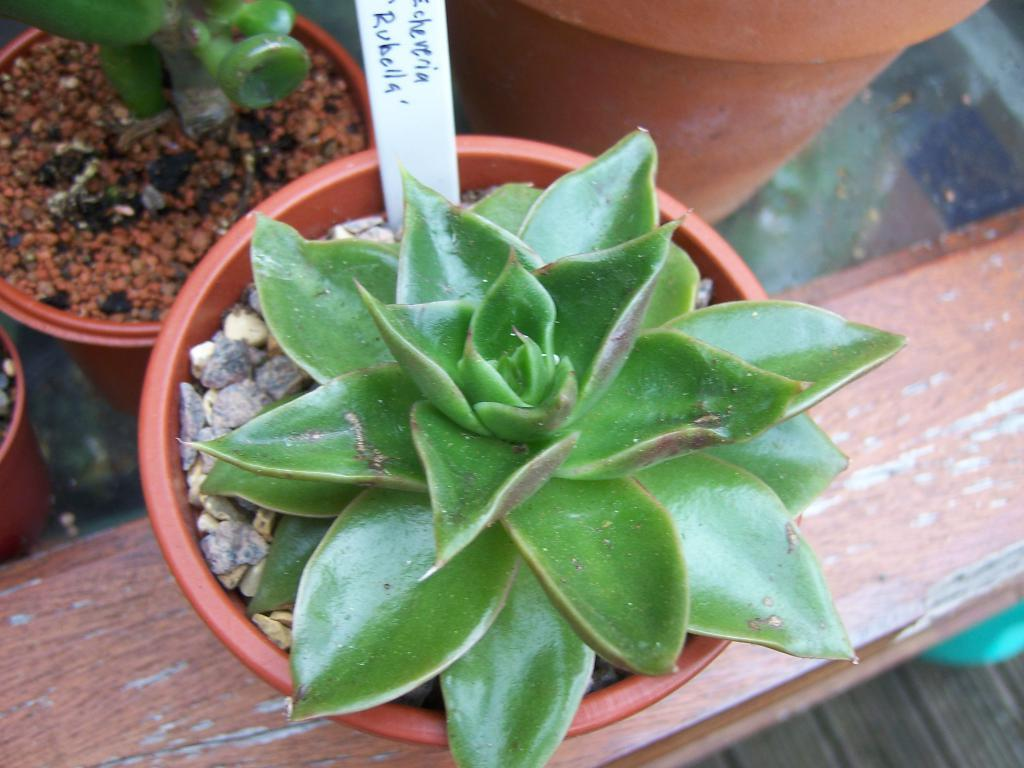What type of living organisms can be seen in the image? Plants can be seen in the image. What color are the pots that the plants are in? The pots are brown in color. Can you describe the white object in the image? There is a white object in the image, but its specific nature is not clear from the facts provided. What is written on the white object? Something is written on the white object, but the content of the writing is not mentioned in the facts provided. What type of soda is being poured from the faucet in the image? There is no soda or faucet present in the image, as the facts only mention plants, brown pots, and a white object with writing on it. 